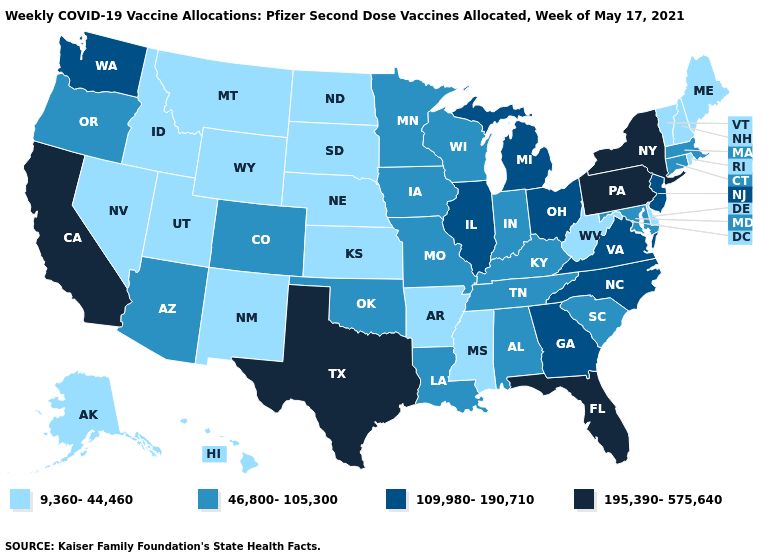How many symbols are there in the legend?
Give a very brief answer. 4. Which states have the highest value in the USA?
Be succinct. California, Florida, New York, Pennsylvania, Texas. What is the highest value in the MidWest ?
Concise answer only. 109,980-190,710. What is the value of New Mexico?
Keep it brief. 9,360-44,460. Does Missouri have the lowest value in the MidWest?
Short answer required. No. Among the states that border Illinois , which have the lowest value?
Concise answer only. Indiana, Iowa, Kentucky, Missouri, Wisconsin. Which states hav the highest value in the MidWest?
Concise answer only. Illinois, Michigan, Ohio. What is the value of Georgia?
Be succinct. 109,980-190,710. What is the value of Michigan?
Quick response, please. 109,980-190,710. Does Washington have a lower value than Pennsylvania?
Give a very brief answer. Yes. What is the value of North Dakota?
Concise answer only. 9,360-44,460. What is the value of Pennsylvania?
Be succinct. 195,390-575,640. What is the lowest value in states that border Nevada?
Be succinct. 9,360-44,460. What is the value of Michigan?
Write a very short answer. 109,980-190,710. Among the states that border Missouri , which have the highest value?
Keep it brief. Illinois. 